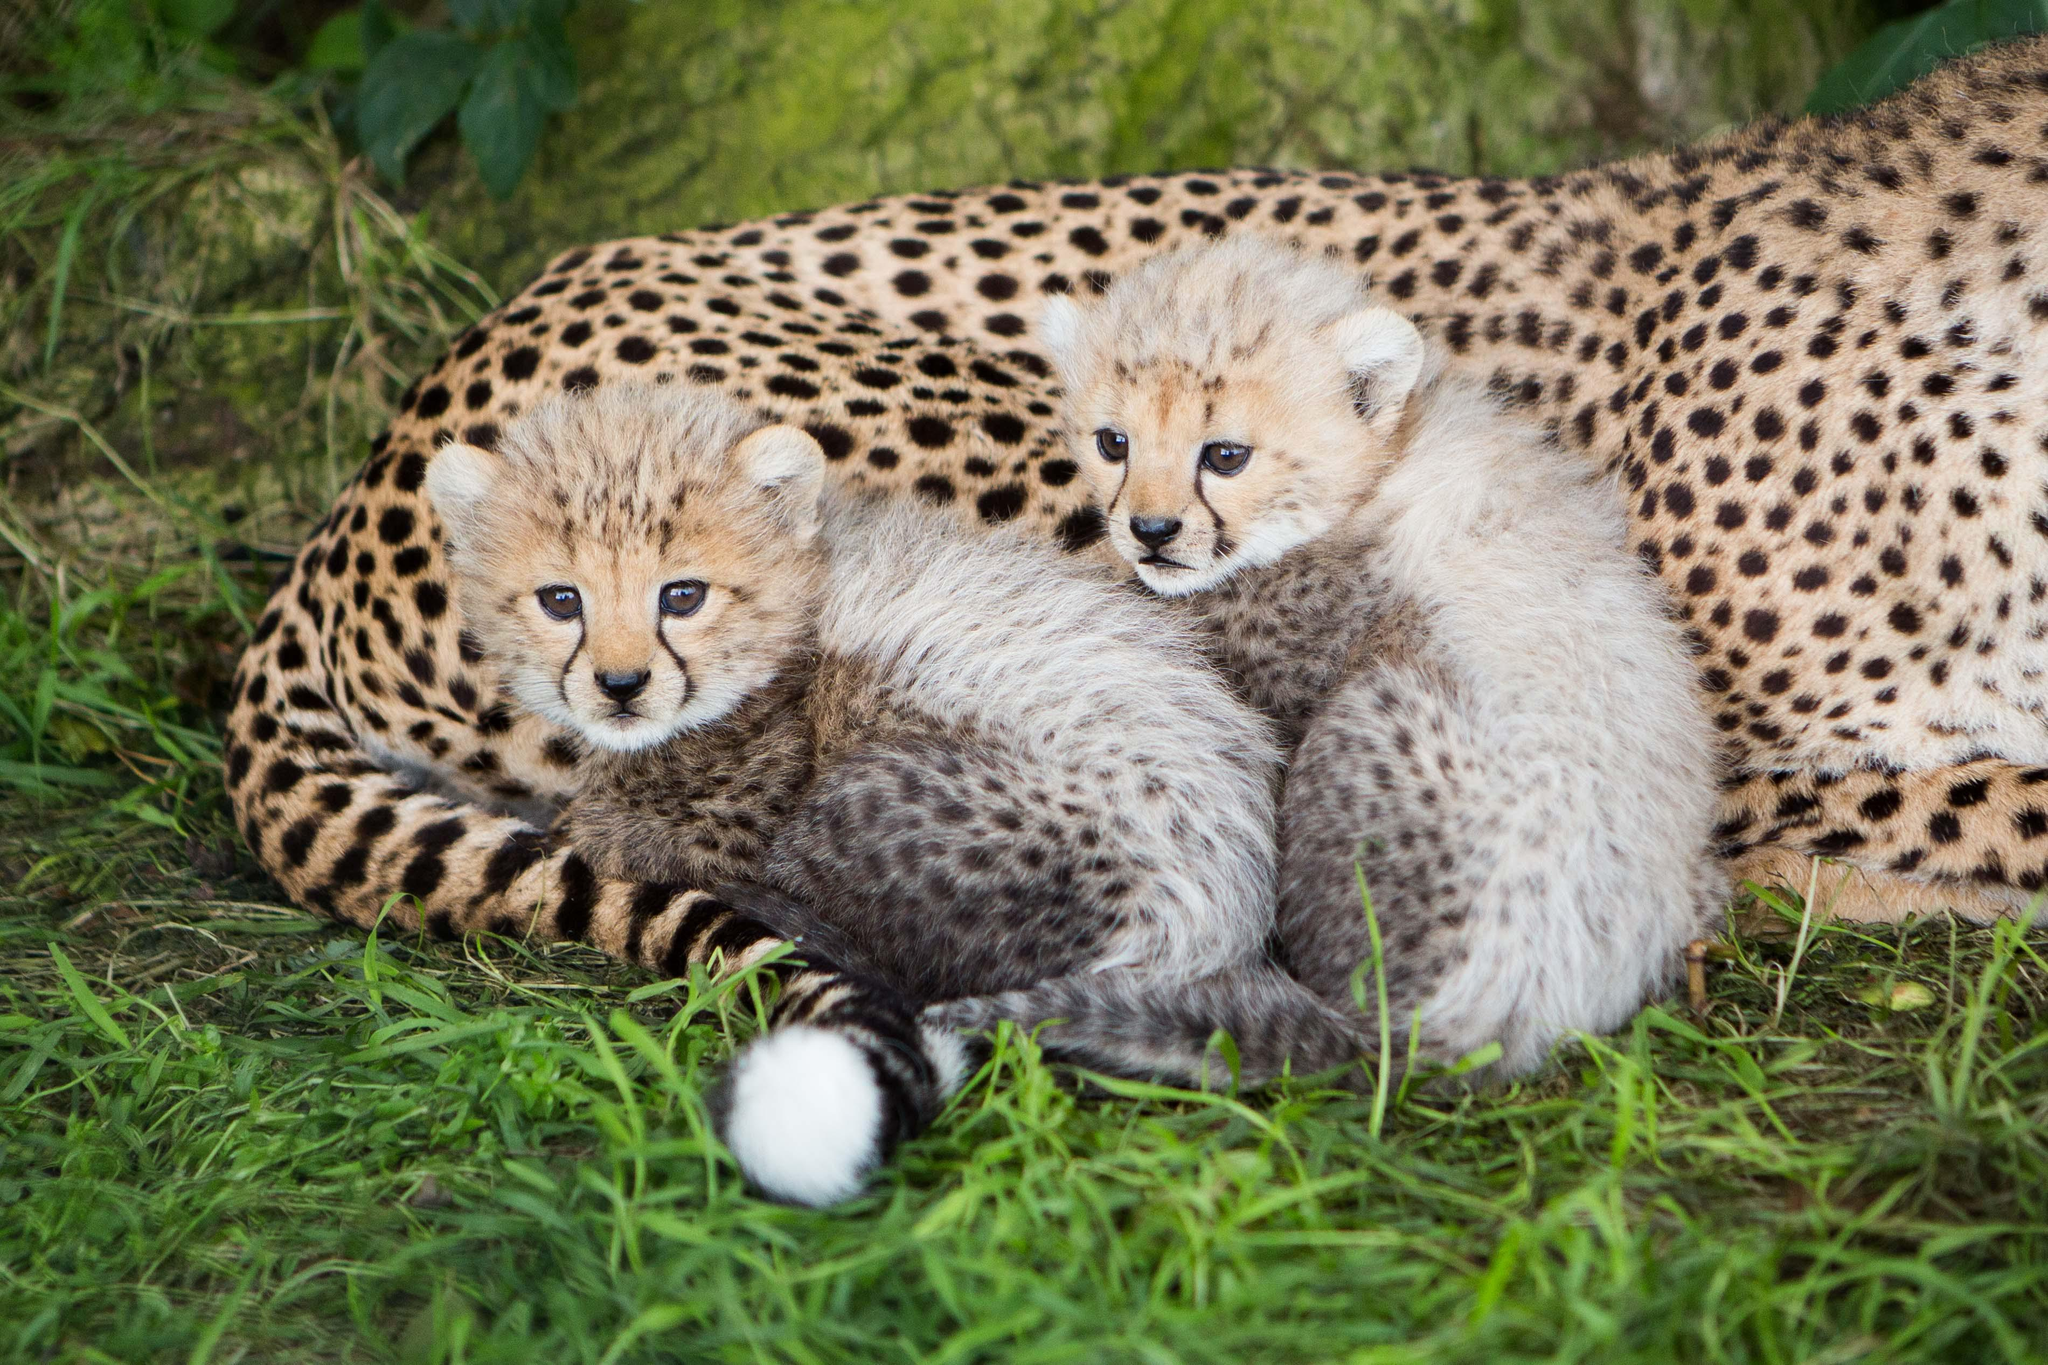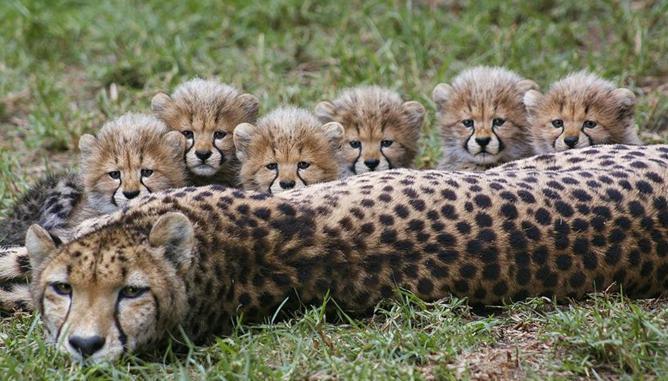The first image is the image on the left, the second image is the image on the right. Given the left and right images, does the statement "An image contains exactly one cheetah." hold true? Answer yes or no. No. The first image is the image on the left, the second image is the image on the right. For the images shown, is this caption "The combined images include at least one adult cheetah and at least six fuzzy-headed baby cheetahs." true? Answer yes or no. Yes. 